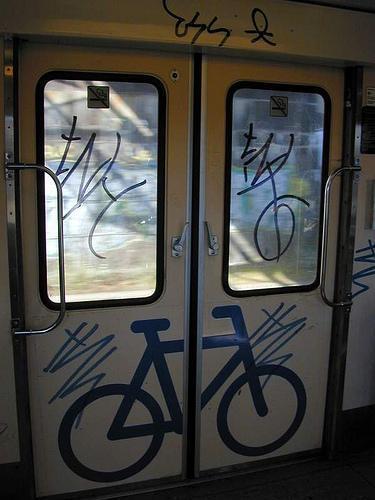How many doors do you see?
Give a very brief answer. 2. 